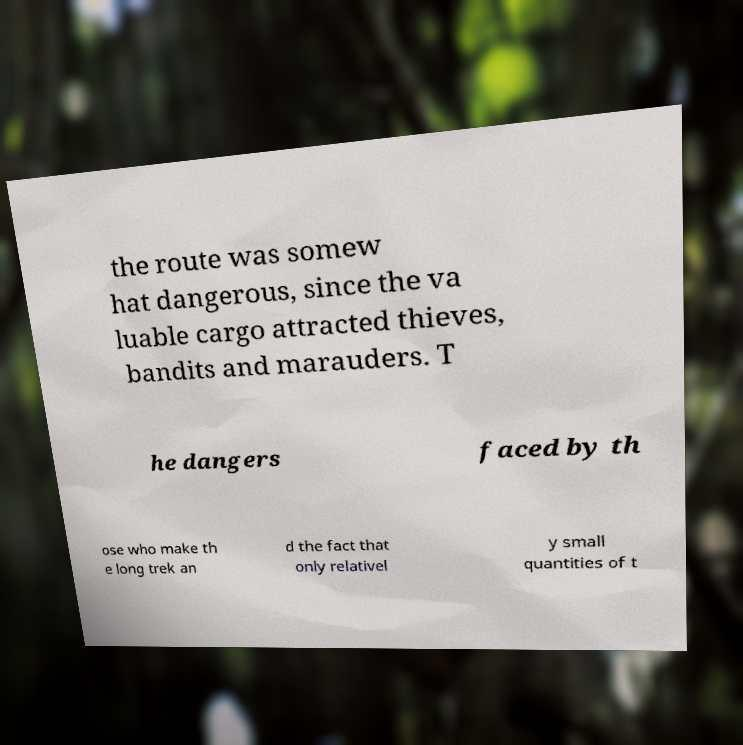There's text embedded in this image that I need extracted. Can you transcribe it verbatim? the route was somew hat dangerous, since the va luable cargo attracted thieves, bandits and marauders. T he dangers faced by th ose who make th e long trek an d the fact that only relativel y small quantities of t 